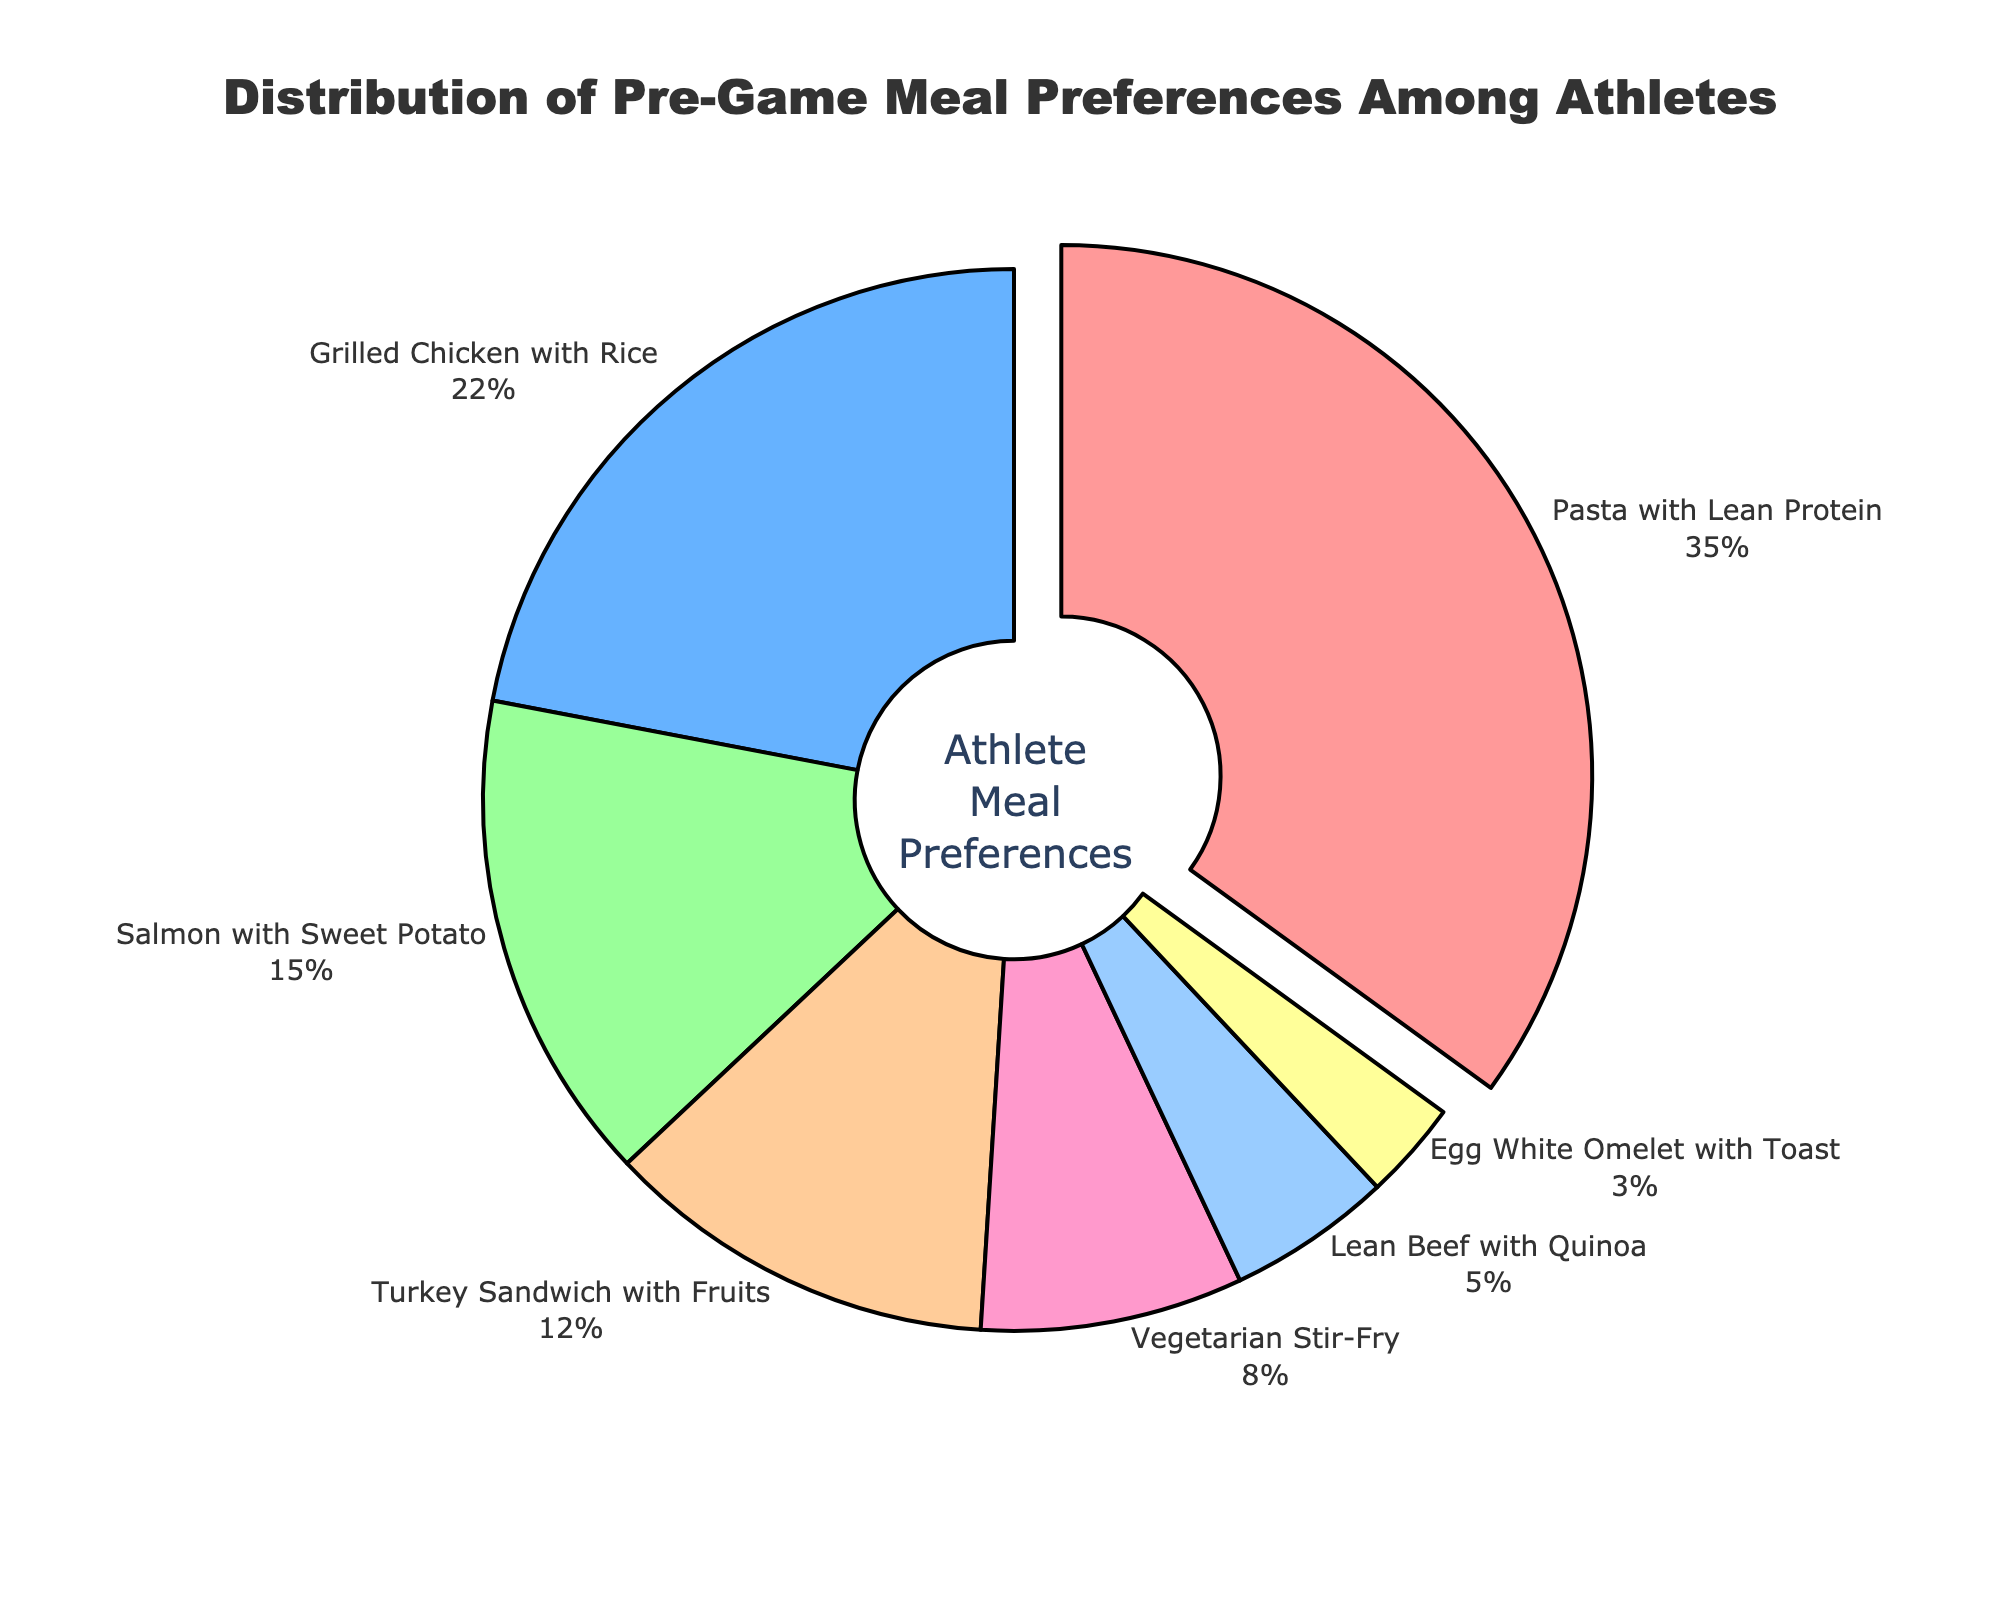What's the most preferred pre-game meal among athletes? The pie chart shows several meal options with their respective percentages. "Pasta with Lean Protein" has the largest segment, which is 35% of the total preferences.
Answer: Pasta with Lean Protein Which meal has the smallest percentage of athletes preferring it? The segment representing "Egg White Omelet with Toast" is the smallest in the pie chart with only 3% of the total preferences.
Answer: Egg White Omelet with Toast What's the combined percentage of athletes who prefer "Salmon with Sweet Potato" and "Turkey Sandwich with Fruits"? From the chart, "Salmon with Sweet Potato" is 15% and "Turkey Sandwich with Fruits" is 12%. Adding these two percentages, 15% + 12%, gives a combined total of 27%.
Answer: 27% How does the preference for "Grilled Chicken with Rice" compare to "Vegetarian Stir-Fry"? According to the chart, "Grilled Chicken with Rice" has 22% of the preferences while "Vegetarian Stir-Fry" has 8%. Comparing these, 22% is greater than 8%.
Answer: Grilled Chicken with Rice has more preferences What is the difference in percentage between "Pasta with Lean Protein" and "Lean Beef with Quinoa"? The chart shows "Pasta with Lean Protein" at 35% and "Lean Beef with Quinoa" at 5%. The difference is calculated as 35% - 5% = 30%.
Answer: 30% If you sum up the preferences for "Turkey Sandwich with Fruits," "Vegetarian Stir-Fry," and "Lean Beef with Quinoa," what percentage do you get? From the chart, "Turkey Sandwich with Fruits" is 12%, "Vegetarian Stir-Fry" is 8%, and "Lean Beef with Quinoa" is 5%. Adding these together, 12% + 8% + 5% = 25%.
Answer: 25% What color represents "Pasta with Lean Protein" in the pie chart? According to the visual attributes of the pie chart, "Pasta with Lean Protein" is represented by the color red.
Answer: Red Is the segment for "Grilled Chicken with Rice" pulled out slightly from the center, and if so, why? The segment representing "Grilled Chicken with Rice" is not pulled out from the center. Only the segment with the highest percentage, "Pasta with Lean Protein," is pulled out.
Answer: No Which meals have less than 10% preference among athletes? From the chart, "Vegetarian Stir-Fry" has 8%, "Lean Beef with Quinoa" has 5%, and "Egg White Omelet with Toast" has 3%. All these have less than 10% preference.
Answer: Vegetarian Stir-Fry, Lean Beef with Quinoa, Egg White Omelet with Toast What's the total percentage of athletes preferring either "Pasta with Lean Protein" or "Grilled Chicken with Rice"? The chart shows "Pasta with Lean Protein" at 35% and "Grilled Chicken with Rice" at 22%. Adding these two figures, 35% + 22%, gives a total of 57%.
Answer: 57% 